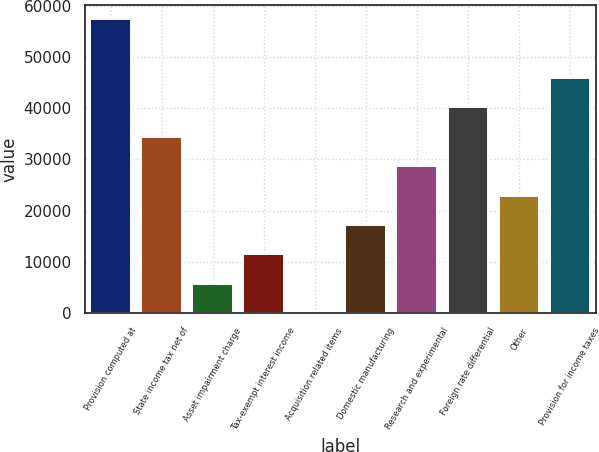<chart> <loc_0><loc_0><loc_500><loc_500><bar_chart><fcel>Provision computed at<fcel>State income tax net of<fcel>Asset impairment charge<fcel>Tax-exempt interest income<fcel>Acquisition related items<fcel>Domestic manufacturing<fcel>Research and experimental<fcel>Foreign rate differential<fcel>Other<fcel>Provision for income taxes<nl><fcel>57339<fcel>34404.4<fcel>5736.23<fcel>11469.9<fcel>2.59<fcel>17203.5<fcel>28670.8<fcel>40138.1<fcel>22937.2<fcel>45871.7<nl></chart> 